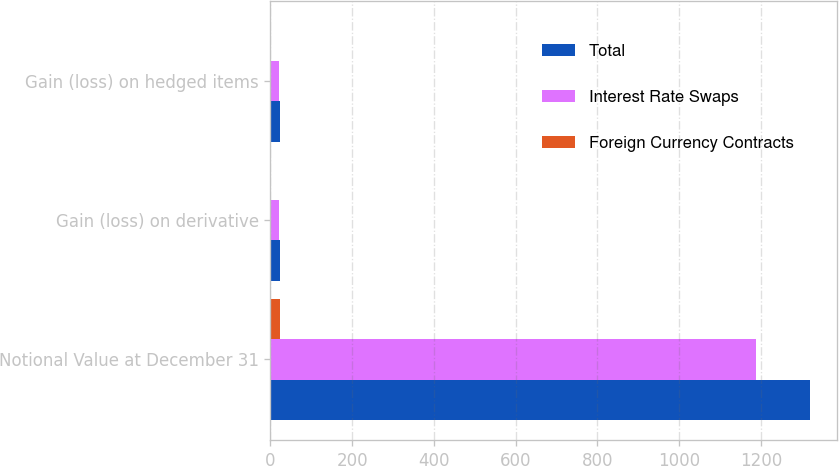<chart> <loc_0><loc_0><loc_500><loc_500><stacked_bar_chart><ecel><fcel>Notional Value at December 31<fcel>Gain (loss) on derivative<fcel>Gain (loss) on hedged items<nl><fcel>Total<fcel>1320<fcel>24<fcel>24<nl><fcel>Interest Rate Swaps<fcel>1188<fcel>22<fcel>22<nl><fcel>Foreign Currency Contracts<fcel>23<fcel>2<fcel>2<nl></chart> 